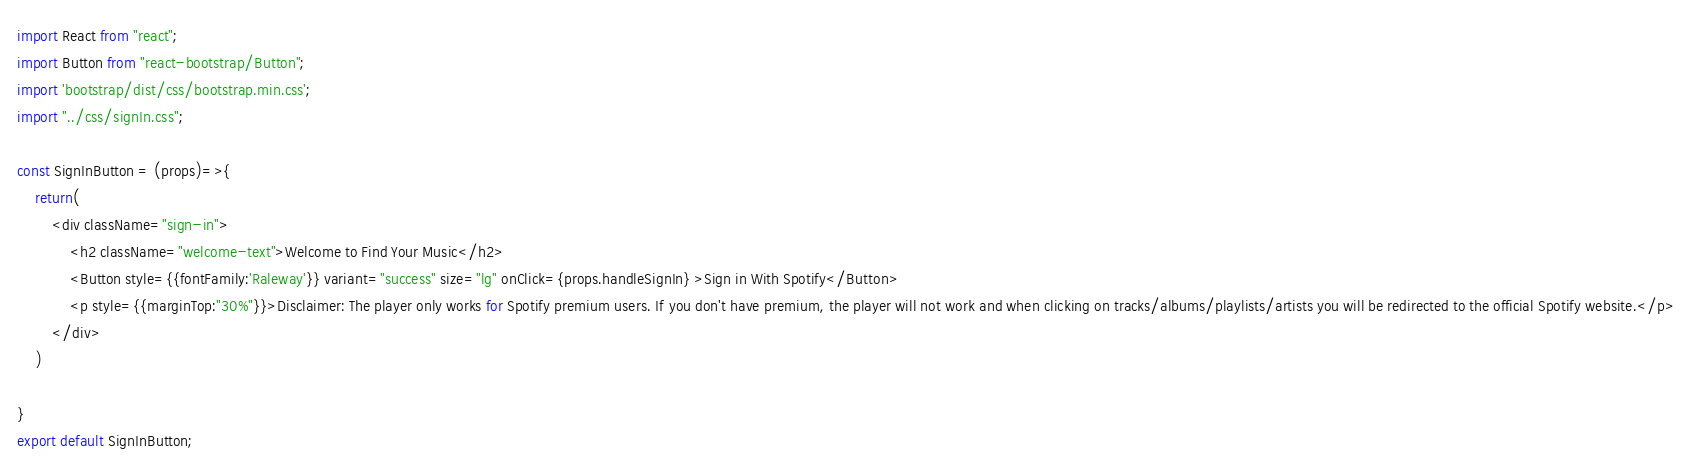Convert code to text. <code><loc_0><loc_0><loc_500><loc_500><_JavaScript_>import React from "react";
import Button from "react-bootstrap/Button";
import 'bootstrap/dist/css/bootstrap.min.css';
import "../css/signIn.css";

const SignInButton = (props)=>{
    return(
        <div className="sign-in">
            <h2 className="welcome-text">Welcome to Find Your Music</h2>
            <Button style={{fontFamily:'Raleway'}} variant="success" size="lg" onClick={props.handleSignIn} >Sign in With Spotify</Button>
            <p style={{marginTop:"30%"}}>Disclaimer: The player only works for Spotify premium users. If you don't have premium, the player will not work and when clicking on tracks/albums/playlists/artists you will be redirected to the official Spotify website.</p>
        </div>   
    )
    
}
export default SignInButton;</code> 